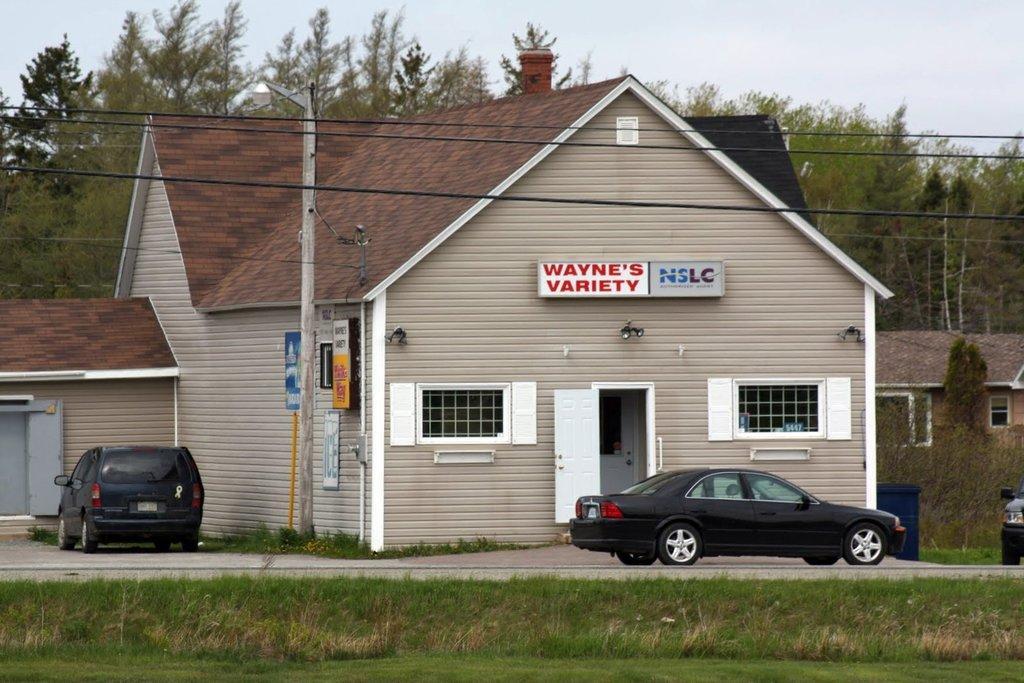How would you summarize this image in a sentence or two? In this image, we can see cars in front of the shelter house. There is a pole in the middle of the image. In the background of the image, we can see some trees and sky. There is a grass on the ground. 